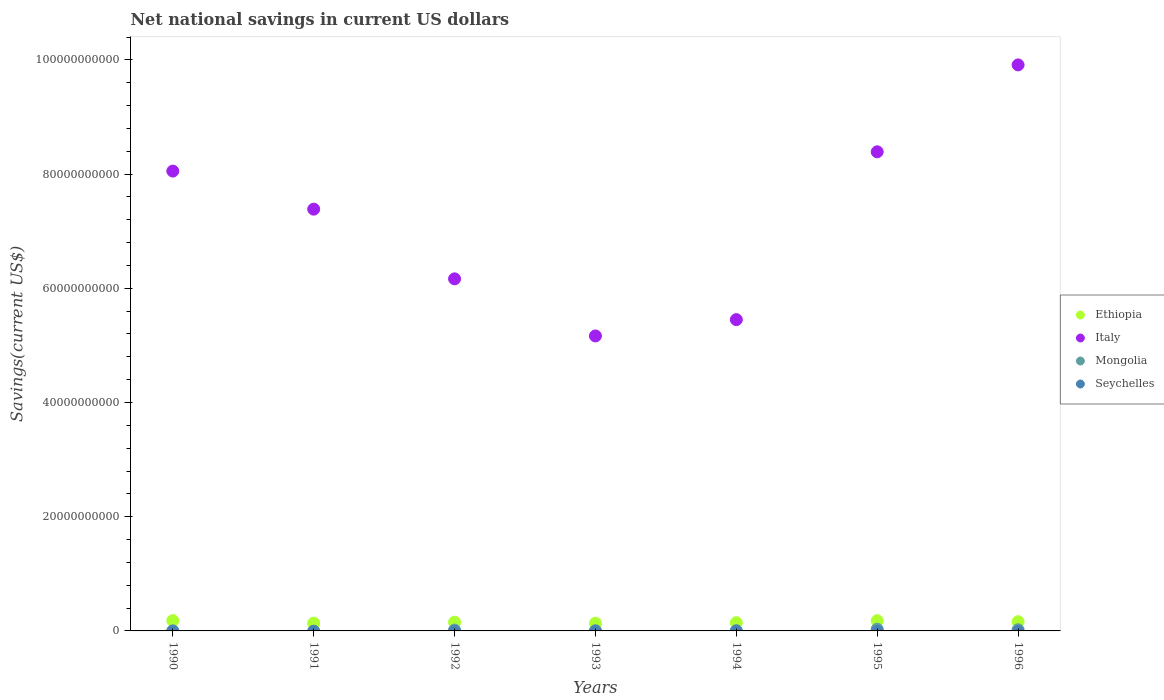Is the number of dotlines equal to the number of legend labels?
Offer a terse response. No. What is the net national savings in Italy in 1993?
Provide a succinct answer. 5.17e+1. Across all years, what is the maximum net national savings in Ethiopia?
Your answer should be compact. 1.80e+09. Across all years, what is the minimum net national savings in Ethiopia?
Keep it short and to the point. 1.35e+09. In which year was the net national savings in Ethiopia maximum?
Provide a short and direct response. 1990. What is the difference between the net national savings in Ethiopia in 1992 and that in 1993?
Provide a short and direct response. 1.73e+08. What is the difference between the net national savings in Ethiopia in 1993 and the net national savings in Mongolia in 1990?
Your answer should be compact. 1.33e+09. What is the average net national savings in Mongolia per year?
Provide a succinct answer. 1.11e+08. In the year 1992, what is the difference between the net national savings in Mongolia and net national savings in Italy?
Keep it short and to the point. -6.15e+1. In how many years, is the net national savings in Seychelles greater than 88000000000 US$?
Offer a very short reply. 0. What is the ratio of the net national savings in Ethiopia in 1995 to that in 1996?
Ensure brevity in your answer.  1.1. Is the net national savings in Ethiopia in 1991 less than that in 1993?
Your response must be concise. No. Is the difference between the net national savings in Mongolia in 1990 and 1992 greater than the difference between the net national savings in Italy in 1990 and 1992?
Your answer should be compact. No. What is the difference between the highest and the second highest net national savings in Italy?
Offer a very short reply. 1.52e+1. What is the difference between the highest and the lowest net national savings in Ethiopia?
Provide a succinct answer. 4.46e+08. In how many years, is the net national savings in Mongolia greater than the average net national savings in Mongolia taken over all years?
Make the answer very short. 3. Is the sum of the net national savings in Italy in 1990 and 1991 greater than the maximum net national savings in Ethiopia across all years?
Make the answer very short. Yes. Is it the case that in every year, the sum of the net national savings in Mongolia and net national savings in Seychelles  is greater than the sum of net national savings in Ethiopia and net national savings in Italy?
Keep it short and to the point. No. Does the net national savings in Mongolia monotonically increase over the years?
Give a very brief answer. No. Is the net national savings in Seychelles strictly greater than the net national savings in Italy over the years?
Ensure brevity in your answer.  No. How many years are there in the graph?
Your response must be concise. 7. What is the difference between two consecutive major ticks on the Y-axis?
Give a very brief answer. 2.00e+1. Does the graph contain grids?
Offer a very short reply. No. How are the legend labels stacked?
Make the answer very short. Vertical. What is the title of the graph?
Offer a terse response. Net national savings in current US dollars. What is the label or title of the Y-axis?
Make the answer very short. Savings(current US$). What is the Savings(current US$) of Ethiopia in 1990?
Keep it short and to the point. 1.80e+09. What is the Savings(current US$) of Italy in 1990?
Your answer should be compact. 8.05e+1. What is the Savings(current US$) in Mongolia in 1990?
Keep it short and to the point. 2.00e+07. What is the Savings(current US$) of Ethiopia in 1991?
Ensure brevity in your answer.  1.37e+09. What is the Savings(current US$) in Italy in 1991?
Keep it short and to the point. 7.39e+1. What is the Savings(current US$) of Seychelles in 1991?
Offer a terse response. 0. What is the Savings(current US$) in Ethiopia in 1992?
Your answer should be very brief. 1.53e+09. What is the Savings(current US$) in Italy in 1992?
Keep it short and to the point. 6.17e+1. What is the Savings(current US$) in Mongolia in 1992?
Your answer should be compact. 1.51e+08. What is the Savings(current US$) of Ethiopia in 1993?
Give a very brief answer. 1.35e+09. What is the Savings(current US$) of Italy in 1993?
Provide a short and direct response. 5.17e+1. What is the Savings(current US$) of Mongolia in 1993?
Ensure brevity in your answer.  4.55e+07. What is the Savings(current US$) in Seychelles in 1993?
Offer a terse response. 0. What is the Savings(current US$) of Ethiopia in 1994?
Give a very brief answer. 1.44e+09. What is the Savings(current US$) of Italy in 1994?
Provide a succinct answer. 5.45e+1. What is the Savings(current US$) of Mongolia in 1994?
Make the answer very short. 5.09e+07. What is the Savings(current US$) of Seychelles in 1994?
Ensure brevity in your answer.  0. What is the Savings(current US$) of Ethiopia in 1995?
Provide a short and direct response. 1.79e+09. What is the Savings(current US$) in Italy in 1995?
Your response must be concise. 8.39e+1. What is the Savings(current US$) in Mongolia in 1995?
Give a very brief answer. 3.06e+08. What is the Savings(current US$) of Seychelles in 1995?
Your response must be concise. 0. What is the Savings(current US$) in Ethiopia in 1996?
Provide a short and direct response. 1.62e+09. What is the Savings(current US$) in Italy in 1996?
Keep it short and to the point. 9.91e+1. What is the Savings(current US$) in Mongolia in 1996?
Give a very brief answer. 2.02e+08. Across all years, what is the maximum Savings(current US$) of Ethiopia?
Your answer should be compact. 1.80e+09. Across all years, what is the maximum Savings(current US$) in Italy?
Provide a succinct answer. 9.91e+1. Across all years, what is the maximum Savings(current US$) of Mongolia?
Provide a succinct answer. 3.06e+08. Across all years, what is the minimum Savings(current US$) in Ethiopia?
Provide a short and direct response. 1.35e+09. Across all years, what is the minimum Savings(current US$) in Italy?
Make the answer very short. 5.17e+1. Across all years, what is the minimum Savings(current US$) of Mongolia?
Give a very brief answer. 0. What is the total Savings(current US$) of Ethiopia in the graph?
Provide a succinct answer. 1.09e+1. What is the total Savings(current US$) in Italy in the graph?
Keep it short and to the point. 5.05e+11. What is the total Savings(current US$) in Mongolia in the graph?
Your response must be concise. 7.75e+08. What is the total Savings(current US$) in Seychelles in the graph?
Keep it short and to the point. 0. What is the difference between the Savings(current US$) of Ethiopia in 1990 and that in 1991?
Offer a terse response. 4.34e+08. What is the difference between the Savings(current US$) in Italy in 1990 and that in 1991?
Make the answer very short. 6.66e+09. What is the difference between the Savings(current US$) in Ethiopia in 1990 and that in 1992?
Give a very brief answer. 2.73e+08. What is the difference between the Savings(current US$) in Italy in 1990 and that in 1992?
Offer a terse response. 1.89e+1. What is the difference between the Savings(current US$) in Mongolia in 1990 and that in 1992?
Your response must be concise. -1.31e+08. What is the difference between the Savings(current US$) in Ethiopia in 1990 and that in 1993?
Your response must be concise. 4.46e+08. What is the difference between the Savings(current US$) of Italy in 1990 and that in 1993?
Your answer should be very brief. 2.89e+1. What is the difference between the Savings(current US$) in Mongolia in 1990 and that in 1993?
Your answer should be very brief. -2.55e+07. What is the difference between the Savings(current US$) in Ethiopia in 1990 and that in 1994?
Provide a short and direct response. 3.58e+08. What is the difference between the Savings(current US$) of Italy in 1990 and that in 1994?
Offer a very short reply. 2.60e+1. What is the difference between the Savings(current US$) in Mongolia in 1990 and that in 1994?
Provide a succinct answer. -3.08e+07. What is the difference between the Savings(current US$) in Ethiopia in 1990 and that in 1995?
Your response must be concise. 1.17e+07. What is the difference between the Savings(current US$) of Italy in 1990 and that in 1995?
Offer a very short reply. -3.38e+09. What is the difference between the Savings(current US$) of Mongolia in 1990 and that in 1995?
Keep it short and to the point. -2.86e+08. What is the difference between the Savings(current US$) of Ethiopia in 1990 and that in 1996?
Provide a short and direct response. 1.80e+08. What is the difference between the Savings(current US$) in Italy in 1990 and that in 1996?
Give a very brief answer. -1.86e+1. What is the difference between the Savings(current US$) of Mongolia in 1990 and that in 1996?
Offer a terse response. -1.82e+08. What is the difference between the Savings(current US$) in Ethiopia in 1991 and that in 1992?
Offer a terse response. -1.61e+08. What is the difference between the Savings(current US$) in Italy in 1991 and that in 1992?
Keep it short and to the point. 1.22e+1. What is the difference between the Savings(current US$) of Ethiopia in 1991 and that in 1993?
Ensure brevity in your answer.  1.20e+07. What is the difference between the Savings(current US$) of Italy in 1991 and that in 1993?
Make the answer very short. 2.22e+1. What is the difference between the Savings(current US$) of Ethiopia in 1991 and that in 1994?
Offer a very short reply. -7.67e+07. What is the difference between the Savings(current US$) of Italy in 1991 and that in 1994?
Your response must be concise. 1.93e+1. What is the difference between the Savings(current US$) in Ethiopia in 1991 and that in 1995?
Offer a terse response. -4.23e+08. What is the difference between the Savings(current US$) in Italy in 1991 and that in 1995?
Make the answer very short. -1.00e+1. What is the difference between the Savings(current US$) in Ethiopia in 1991 and that in 1996?
Keep it short and to the point. -2.54e+08. What is the difference between the Savings(current US$) in Italy in 1991 and that in 1996?
Provide a succinct answer. -2.53e+1. What is the difference between the Savings(current US$) of Ethiopia in 1992 and that in 1993?
Provide a succinct answer. 1.73e+08. What is the difference between the Savings(current US$) in Italy in 1992 and that in 1993?
Make the answer very short. 1.00e+1. What is the difference between the Savings(current US$) of Mongolia in 1992 and that in 1993?
Your answer should be compact. 1.05e+08. What is the difference between the Savings(current US$) of Ethiopia in 1992 and that in 1994?
Ensure brevity in your answer.  8.42e+07. What is the difference between the Savings(current US$) in Italy in 1992 and that in 1994?
Keep it short and to the point. 7.14e+09. What is the difference between the Savings(current US$) in Mongolia in 1992 and that in 1994?
Make the answer very short. 9.97e+07. What is the difference between the Savings(current US$) of Ethiopia in 1992 and that in 1995?
Give a very brief answer. -2.62e+08. What is the difference between the Savings(current US$) of Italy in 1992 and that in 1995?
Provide a short and direct response. -2.22e+1. What is the difference between the Savings(current US$) in Mongolia in 1992 and that in 1995?
Provide a succinct answer. -1.56e+08. What is the difference between the Savings(current US$) in Ethiopia in 1992 and that in 1996?
Provide a succinct answer. -9.32e+07. What is the difference between the Savings(current US$) in Italy in 1992 and that in 1996?
Provide a short and direct response. -3.75e+1. What is the difference between the Savings(current US$) of Mongolia in 1992 and that in 1996?
Give a very brief answer. -5.14e+07. What is the difference between the Savings(current US$) of Ethiopia in 1993 and that in 1994?
Give a very brief answer. -8.88e+07. What is the difference between the Savings(current US$) of Italy in 1993 and that in 1994?
Give a very brief answer. -2.85e+09. What is the difference between the Savings(current US$) of Mongolia in 1993 and that in 1994?
Provide a short and direct response. -5.35e+06. What is the difference between the Savings(current US$) of Ethiopia in 1993 and that in 1995?
Give a very brief answer. -4.35e+08. What is the difference between the Savings(current US$) in Italy in 1993 and that in 1995?
Give a very brief answer. -3.22e+1. What is the difference between the Savings(current US$) in Mongolia in 1993 and that in 1995?
Offer a very short reply. -2.61e+08. What is the difference between the Savings(current US$) in Ethiopia in 1993 and that in 1996?
Keep it short and to the point. -2.66e+08. What is the difference between the Savings(current US$) in Italy in 1993 and that in 1996?
Give a very brief answer. -4.75e+1. What is the difference between the Savings(current US$) in Mongolia in 1993 and that in 1996?
Provide a short and direct response. -1.56e+08. What is the difference between the Savings(current US$) of Ethiopia in 1994 and that in 1995?
Ensure brevity in your answer.  -3.46e+08. What is the difference between the Savings(current US$) in Italy in 1994 and that in 1995?
Make the answer very short. -2.94e+1. What is the difference between the Savings(current US$) in Mongolia in 1994 and that in 1995?
Provide a succinct answer. -2.55e+08. What is the difference between the Savings(current US$) in Ethiopia in 1994 and that in 1996?
Your answer should be very brief. -1.77e+08. What is the difference between the Savings(current US$) in Italy in 1994 and that in 1996?
Your answer should be very brief. -4.46e+1. What is the difference between the Savings(current US$) of Mongolia in 1994 and that in 1996?
Keep it short and to the point. -1.51e+08. What is the difference between the Savings(current US$) of Ethiopia in 1995 and that in 1996?
Your response must be concise. 1.68e+08. What is the difference between the Savings(current US$) in Italy in 1995 and that in 1996?
Your answer should be very brief. -1.52e+1. What is the difference between the Savings(current US$) in Mongolia in 1995 and that in 1996?
Offer a very short reply. 1.04e+08. What is the difference between the Savings(current US$) of Ethiopia in 1990 and the Savings(current US$) of Italy in 1991?
Provide a short and direct response. -7.21e+1. What is the difference between the Savings(current US$) of Ethiopia in 1990 and the Savings(current US$) of Italy in 1992?
Give a very brief answer. -5.99e+1. What is the difference between the Savings(current US$) of Ethiopia in 1990 and the Savings(current US$) of Mongolia in 1992?
Offer a very short reply. 1.65e+09. What is the difference between the Savings(current US$) in Italy in 1990 and the Savings(current US$) in Mongolia in 1992?
Your response must be concise. 8.04e+1. What is the difference between the Savings(current US$) of Ethiopia in 1990 and the Savings(current US$) of Italy in 1993?
Offer a very short reply. -4.99e+1. What is the difference between the Savings(current US$) in Ethiopia in 1990 and the Savings(current US$) in Mongolia in 1993?
Give a very brief answer. 1.75e+09. What is the difference between the Savings(current US$) of Italy in 1990 and the Savings(current US$) of Mongolia in 1993?
Offer a terse response. 8.05e+1. What is the difference between the Savings(current US$) in Ethiopia in 1990 and the Savings(current US$) in Italy in 1994?
Ensure brevity in your answer.  -5.27e+1. What is the difference between the Savings(current US$) of Ethiopia in 1990 and the Savings(current US$) of Mongolia in 1994?
Ensure brevity in your answer.  1.75e+09. What is the difference between the Savings(current US$) of Italy in 1990 and the Savings(current US$) of Mongolia in 1994?
Offer a very short reply. 8.05e+1. What is the difference between the Savings(current US$) in Ethiopia in 1990 and the Savings(current US$) in Italy in 1995?
Offer a very short reply. -8.21e+1. What is the difference between the Savings(current US$) of Ethiopia in 1990 and the Savings(current US$) of Mongolia in 1995?
Make the answer very short. 1.49e+09. What is the difference between the Savings(current US$) of Italy in 1990 and the Savings(current US$) of Mongolia in 1995?
Offer a very short reply. 8.02e+1. What is the difference between the Savings(current US$) of Ethiopia in 1990 and the Savings(current US$) of Italy in 1996?
Make the answer very short. -9.73e+1. What is the difference between the Savings(current US$) of Ethiopia in 1990 and the Savings(current US$) of Mongolia in 1996?
Your answer should be very brief. 1.60e+09. What is the difference between the Savings(current US$) in Italy in 1990 and the Savings(current US$) in Mongolia in 1996?
Ensure brevity in your answer.  8.03e+1. What is the difference between the Savings(current US$) of Ethiopia in 1991 and the Savings(current US$) of Italy in 1992?
Your answer should be compact. -6.03e+1. What is the difference between the Savings(current US$) in Ethiopia in 1991 and the Savings(current US$) in Mongolia in 1992?
Your response must be concise. 1.21e+09. What is the difference between the Savings(current US$) in Italy in 1991 and the Savings(current US$) in Mongolia in 1992?
Give a very brief answer. 7.37e+1. What is the difference between the Savings(current US$) of Ethiopia in 1991 and the Savings(current US$) of Italy in 1993?
Offer a terse response. -5.03e+1. What is the difference between the Savings(current US$) in Ethiopia in 1991 and the Savings(current US$) in Mongolia in 1993?
Make the answer very short. 1.32e+09. What is the difference between the Savings(current US$) in Italy in 1991 and the Savings(current US$) in Mongolia in 1993?
Your answer should be very brief. 7.38e+1. What is the difference between the Savings(current US$) in Ethiopia in 1991 and the Savings(current US$) in Italy in 1994?
Offer a very short reply. -5.31e+1. What is the difference between the Savings(current US$) in Ethiopia in 1991 and the Savings(current US$) in Mongolia in 1994?
Make the answer very short. 1.31e+09. What is the difference between the Savings(current US$) in Italy in 1991 and the Savings(current US$) in Mongolia in 1994?
Your response must be concise. 7.38e+1. What is the difference between the Savings(current US$) of Ethiopia in 1991 and the Savings(current US$) of Italy in 1995?
Give a very brief answer. -8.25e+1. What is the difference between the Savings(current US$) of Ethiopia in 1991 and the Savings(current US$) of Mongolia in 1995?
Provide a succinct answer. 1.06e+09. What is the difference between the Savings(current US$) of Italy in 1991 and the Savings(current US$) of Mongolia in 1995?
Provide a short and direct response. 7.36e+1. What is the difference between the Savings(current US$) of Ethiopia in 1991 and the Savings(current US$) of Italy in 1996?
Your answer should be very brief. -9.78e+1. What is the difference between the Savings(current US$) in Ethiopia in 1991 and the Savings(current US$) in Mongolia in 1996?
Your answer should be very brief. 1.16e+09. What is the difference between the Savings(current US$) in Italy in 1991 and the Savings(current US$) in Mongolia in 1996?
Ensure brevity in your answer.  7.37e+1. What is the difference between the Savings(current US$) in Ethiopia in 1992 and the Savings(current US$) in Italy in 1993?
Your response must be concise. -5.01e+1. What is the difference between the Savings(current US$) of Ethiopia in 1992 and the Savings(current US$) of Mongolia in 1993?
Offer a terse response. 1.48e+09. What is the difference between the Savings(current US$) of Italy in 1992 and the Savings(current US$) of Mongolia in 1993?
Offer a terse response. 6.16e+1. What is the difference between the Savings(current US$) of Ethiopia in 1992 and the Savings(current US$) of Italy in 1994?
Give a very brief answer. -5.30e+1. What is the difference between the Savings(current US$) in Ethiopia in 1992 and the Savings(current US$) in Mongolia in 1994?
Offer a very short reply. 1.48e+09. What is the difference between the Savings(current US$) of Italy in 1992 and the Savings(current US$) of Mongolia in 1994?
Your answer should be very brief. 6.16e+1. What is the difference between the Savings(current US$) in Ethiopia in 1992 and the Savings(current US$) in Italy in 1995?
Provide a succinct answer. -8.24e+1. What is the difference between the Savings(current US$) in Ethiopia in 1992 and the Savings(current US$) in Mongolia in 1995?
Provide a short and direct response. 1.22e+09. What is the difference between the Savings(current US$) in Italy in 1992 and the Savings(current US$) in Mongolia in 1995?
Provide a succinct answer. 6.13e+1. What is the difference between the Savings(current US$) in Ethiopia in 1992 and the Savings(current US$) in Italy in 1996?
Offer a terse response. -9.76e+1. What is the difference between the Savings(current US$) of Ethiopia in 1992 and the Savings(current US$) of Mongolia in 1996?
Your answer should be compact. 1.32e+09. What is the difference between the Savings(current US$) of Italy in 1992 and the Savings(current US$) of Mongolia in 1996?
Your answer should be very brief. 6.15e+1. What is the difference between the Savings(current US$) of Ethiopia in 1993 and the Savings(current US$) of Italy in 1994?
Your answer should be compact. -5.32e+1. What is the difference between the Savings(current US$) of Ethiopia in 1993 and the Savings(current US$) of Mongolia in 1994?
Offer a very short reply. 1.30e+09. What is the difference between the Savings(current US$) of Italy in 1993 and the Savings(current US$) of Mongolia in 1994?
Provide a succinct answer. 5.16e+1. What is the difference between the Savings(current US$) in Ethiopia in 1993 and the Savings(current US$) in Italy in 1995?
Give a very brief answer. -8.25e+1. What is the difference between the Savings(current US$) of Ethiopia in 1993 and the Savings(current US$) of Mongolia in 1995?
Make the answer very short. 1.05e+09. What is the difference between the Savings(current US$) of Italy in 1993 and the Savings(current US$) of Mongolia in 1995?
Ensure brevity in your answer.  5.14e+1. What is the difference between the Savings(current US$) of Ethiopia in 1993 and the Savings(current US$) of Italy in 1996?
Give a very brief answer. -9.78e+1. What is the difference between the Savings(current US$) in Ethiopia in 1993 and the Savings(current US$) in Mongolia in 1996?
Give a very brief answer. 1.15e+09. What is the difference between the Savings(current US$) of Italy in 1993 and the Savings(current US$) of Mongolia in 1996?
Offer a terse response. 5.15e+1. What is the difference between the Savings(current US$) in Ethiopia in 1994 and the Savings(current US$) in Italy in 1995?
Your response must be concise. -8.25e+1. What is the difference between the Savings(current US$) in Ethiopia in 1994 and the Savings(current US$) in Mongolia in 1995?
Ensure brevity in your answer.  1.14e+09. What is the difference between the Savings(current US$) of Italy in 1994 and the Savings(current US$) of Mongolia in 1995?
Your response must be concise. 5.42e+1. What is the difference between the Savings(current US$) of Ethiopia in 1994 and the Savings(current US$) of Italy in 1996?
Provide a short and direct response. -9.77e+1. What is the difference between the Savings(current US$) of Ethiopia in 1994 and the Savings(current US$) of Mongolia in 1996?
Ensure brevity in your answer.  1.24e+09. What is the difference between the Savings(current US$) of Italy in 1994 and the Savings(current US$) of Mongolia in 1996?
Make the answer very short. 5.43e+1. What is the difference between the Savings(current US$) in Ethiopia in 1995 and the Savings(current US$) in Italy in 1996?
Provide a succinct answer. -9.73e+1. What is the difference between the Savings(current US$) in Ethiopia in 1995 and the Savings(current US$) in Mongolia in 1996?
Keep it short and to the point. 1.59e+09. What is the difference between the Savings(current US$) in Italy in 1995 and the Savings(current US$) in Mongolia in 1996?
Your answer should be compact. 8.37e+1. What is the average Savings(current US$) of Ethiopia per year?
Ensure brevity in your answer.  1.56e+09. What is the average Savings(current US$) of Italy per year?
Offer a very short reply. 7.22e+1. What is the average Savings(current US$) of Mongolia per year?
Your response must be concise. 1.11e+08. What is the average Savings(current US$) in Seychelles per year?
Provide a succinct answer. 0. In the year 1990, what is the difference between the Savings(current US$) of Ethiopia and Savings(current US$) of Italy?
Make the answer very short. -7.87e+1. In the year 1990, what is the difference between the Savings(current US$) in Ethiopia and Savings(current US$) in Mongolia?
Offer a terse response. 1.78e+09. In the year 1990, what is the difference between the Savings(current US$) of Italy and Savings(current US$) of Mongolia?
Give a very brief answer. 8.05e+1. In the year 1991, what is the difference between the Savings(current US$) of Ethiopia and Savings(current US$) of Italy?
Your answer should be compact. -7.25e+1. In the year 1992, what is the difference between the Savings(current US$) in Ethiopia and Savings(current US$) in Italy?
Ensure brevity in your answer.  -6.01e+1. In the year 1992, what is the difference between the Savings(current US$) in Ethiopia and Savings(current US$) in Mongolia?
Provide a short and direct response. 1.38e+09. In the year 1992, what is the difference between the Savings(current US$) of Italy and Savings(current US$) of Mongolia?
Your answer should be compact. 6.15e+1. In the year 1993, what is the difference between the Savings(current US$) in Ethiopia and Savings(current US$) in Italy?
Ensure brevity in your answer.  -5.03e+1. In the year 1993, what is the difference between the Savings(current US$) of Ethiopia and Savings(current US$) of Mongolia?
Keep it short and to the point. 1.31e+09. In the year 1993, what is the difference between the Savings(current US$) in Italy and Savings(current US$) in Mongolia?
Your response must be concise. 5.16e+1. In the year 1994, what is the difference between the Savings(current US$) in Ethiopia and Savings(current US$) in Italy?
Ensure brevity in your answer.  -5.31e+1. In the year 1994, what is the difference between the Savings(current US$) of Ethiopia and Savings(current US$) of Mongolia?
Make the answer very short. 1.39e+09. In the year 1994, what is the difference between the Savings(current US$) in Italy and Savings(current US$) in Mongolia?
Your response must be concise. 5.45e+1. In the year 1995, what is the difference between the Savings(current US$) in Ethiopia and Savings(current US$) in Italy?
Offer a terse response. -8.21e+1. In the year 1995, what is the difference between the Savings(current US$) in Ethiopia and Savings(current US$) in Mongolia?
Your response must be concise. 1.48e+09. In the year 1995, what is the difference between the Savings(current US$) of Italy and Savings(current US$) of Mongolia?
Your answer should be very brief. 8.36e+1. In the year 1996, what is the difference between the Savings(current US$) in Ethiopia and Savings(current US$) in Italy?
Ensure brevity in your answer.  -9.75e+1. In the year 1996, what is the difference between the Savings(current US$) of Ethiopia and Savings(current US$) of Mongolia?
Your response must be concise. 1.42e+09. In the year 1996, what is the difference between the Savings(current US$) in Italy and Savings(current US$) in Mongolia?
Keep it short and to the point. 9.89e+1. What is the ratio of the Savings(current US$) of Ethiopia in 1990 to that in 1991?
Your answer should be very brief. 1.32. What is the ratio of the Savings(current US$) of Italy in 1990 to that in 1991?
Offer a terse response. 1.09. What is the ratio of the Savings(current US$) in Ethiopia in 1990 to that in 1992?
Provide a short and direct response. 1.18. What is the ratio of the Savings(current US$) of Italy in 1990 to that in 1992?
Keep it short and to the point. 1.31. What is the ratio of the Savings(current US$) in Mongolia in 1990 to that in 1992?
Your answer should be compact. 0.13. What is the ratio of the Savings(current US$) in Ethiopia in 1990 to that in 1993?
Your response must be concise. 1.33. What is the ratio of the Savings(current US$) of Italy in 1990 to that in 1993?
Provide a short and direct response. 1.56. What is the ratio of the Savings(current US$) in Mongolia in 1990 to that in 1993?
Offer a terse response. 0.44. What is the ratio of the Savings(current US$) in Ethiopia in 1990 to that in 1994?
Keep it short and to the point. 1.25. What is the ratio of the Savings(current US$) in Italy in 1990 to that in 1994?
Your answer should be compact. 1.48. What is the ratio of the Savings(current US$) in Mongolia in 1990 to that in 1994?
Provide a short and direct response. 0.39. What is the ratio of the Savings(current US$) of Italy in 1990 to that in 1995?
Offer a terse response. 0.96. What is the ratio of the Savings(current US$) in Mongolia in 1990 to that in 1995?
Give a very brief answer. 0.07. What is the ratio of the Savings(current US$) of Ethiopia in 1990 to that in 1996?
Your answer should be compact. 1.11. What is the ratio of the Savings(current US$) of Italy in 1990 to that in 1996?
Provide a short and direct response. 0.81. What is the ratio of the Savings(current US$) of Mongolia in 1990 to that in 1996?
Ensure brevity in your answer.  0.1. What is the ratio of the Savings(current US$) in Ethiopia in 1991 to that in 1992?
Your answer should be compact. 0.89. What is the ratio of the Savings(current US$) of Italy in 1991 to that in 1992?
Provide a succinct answer. 1.2. What is the ratio of the Savings(current US$) of Ethiopia in 1991 to that in 1993?
Give a very brief answer. 1.01. What is the ratio of the Savings(current US$) in Italy in 1991 to that in 1993?
Keep it short and to the point. 1.43. What is the ratio of the Savings(current US$) in Ethiopia in 1991 to that in 1994?
Offer a very short reply. 0.95. What is the ratio of the Savings(current US$) in Italy in 1991 to that in 1994?
Give a very brief answer. 1.35. What is the ratio of the Savings(current US$) of Ethiopia in 1991 to that in 1995?
Give a very brief answer. 0.76. What is the ratio of the Savings(current US$) in Italy in 1991 to that in 1995?
Provide a succinct answer. 0.88. What is the ratio of the Savings(current US$) in Ethiopia in 1991 to that in 1996?
Provide a succinct answer. 0.84. What is the ratio of the Savings(current US$) of Italy in 1991 to that in 1996?
Offer a terse response. 0.75. What is the ratio of the Savings(current US$) of Ethiopia in 1992 to that in 1993?
Your response must be concise. 1.13. What is the ratio of the Savings(current US$) in Italy in 1992 to that in 1993?
Give a very brief answer. 1.19. What is the ratio of the Savings(current US$) in Mongolia in 1992 to that in 1993?
Your answer should be very brief. 3.31. What is the ratio of the Savings(current US$) of Ethiopia in 1992 to that in 1994?
Give a very brief answer. 1.06. What is the ratio of the Savings(current US$) of Italy in 1992 to that in 1994?
Provide a succinct answer. 1.13. What is the ratio of the Savings(current US$) of Mongolia in 1992 to that in 1994?
Your answer should be very brief. 2.96. What is the ratio of the Savings(current US$) of Ethiopia in 1992 to that in 1995?
Give a very brief answer. 0.85. What is the ratio of the Savings(current US$) in Italy in 1992 to that in 1995?
Ensure brevity in your answer.  0.73. What is the ratio of the Savings(current US$) in Mongolia in 1992 to that in 1995?
Your response must be concise. 0.49. What is the ratio of the Savings(current US$) in Ethiopia in 1992 to that in 1996?
Your answer should be very brief. 0.94. What is the ratio of the Savings(current US$) of Italy in 1992 to that in 1996?
Offer a very short reply. 0.62. What is the ratio of the Savings(current US$) of Mongolia in 1992 to that in 1996?
Your response must be concise. 0.75. What is the ratio of the Savings(current US$) of Ethiopia in 1993 to that in 1994?
Make the answer very short. 0.94. What is the ratio of the Savings(current US$) in Italy in 1993 to that in 1994?
Your answer should be very brief. 0.95. What is the ratio of the Savings(current US$) of Mongolia in 1993 to that in 1994?
Your answer should be very brief. 0.89. What is the ratio of the Savings(current US$) in Ethiopia in 1993 to that in 1995?
Make the answer very short. 0.76. What is the ratio of the Savings(current US$) of Italy in 1993 to that in 1995?
Ensure brevity in your answer.  0.62. What is the ratio of the Savings(current US$) in Mongolia in 1993 to that in 1995?
Make the answer very short. 0.15. What is the ratio of the Savings(current US$) in Ethiopia in 1993 to that in 1996?
Your answer should be very brief. 0.84. What is the ratio of the Savings(current US$) of Italy in 1993 to that in 1996?
Offer a terse response. 0.52. What is the ratio of the Savings(current US$) of Mongolia in 1993 to that in 1996?
Your answer should be compact. 0.23. What is the ratio of the Savings(current US$) of Ethiopia in 1994 to that in 1995?
Ensure brevity in your answer.  0.81. What is the ratio of the Savings(current US$) of Italy in 1994 to that in 1995?
Give a very brief answer. 0.65. What is the ratio of the Savings(current US$) in Mongolia in 1994 to that in 1995?
Your answer should be very brief. 0.17. What is the ratio of the Savings(current US$) of Ethiopia in 1994 to that in 1996?
Ensure brevity in your answer.  0.89. What is the ratio of the Savings(current US$) of Italy in 1994 to that in 1996?
Provide a succinct answer. 0.55. What is the ratio of the Savings(current US$) in Mongolia in 1994 to that in 1996?
Ensure brevity in your answer.  0.25. What is the ratio of the Savings(current US$) of Ethiopia in 1995 to that in 1996?
Ensure brevity in your answer.  1.1. What is the ratio of the Savings(current US$) in Italy in 1995 to that in 1996?
Ensure brevity in your answer.  0.85. What is the ratio of the Savings(current US$) in Mongolia in 1995 to that in 1996?
Your answer should be very brief. 1.52. What is the difference between the highest and the second highest Savings(current US$) of Ethiopia?
Keep it short and to the point. 1.17e+07. What is the difference between the highest and the second highest Savings(current US$) in Italy?
Ensure brevity in your answer.  1.52e+1. What is the difference between the highest and the second highest Savings(current US$) of Mongolia?
Your answer should be very brief. 1.04e+08. What is the difference between the highest and the lowest Savings(current US$) in Ethiopia?
Ensure brevity in your answer.  4.46e+08. What is the difference between the highest and the lowest Savings(current US$) of Italy?
Provide a short and direct response. 4.75e+1. What is the difference between the highest and the lowest Savings(current US$) of Mongolia?
Your answer should be very brief. 3.06e+08. 